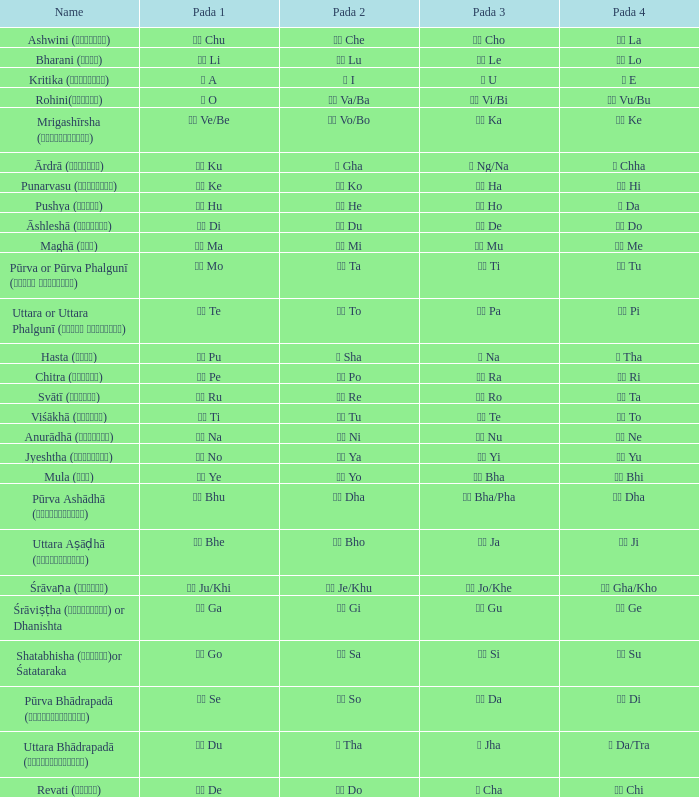Which pada 4 corresponds to a pada 1 that has खी ju/khi? खो Gha/Kho. 